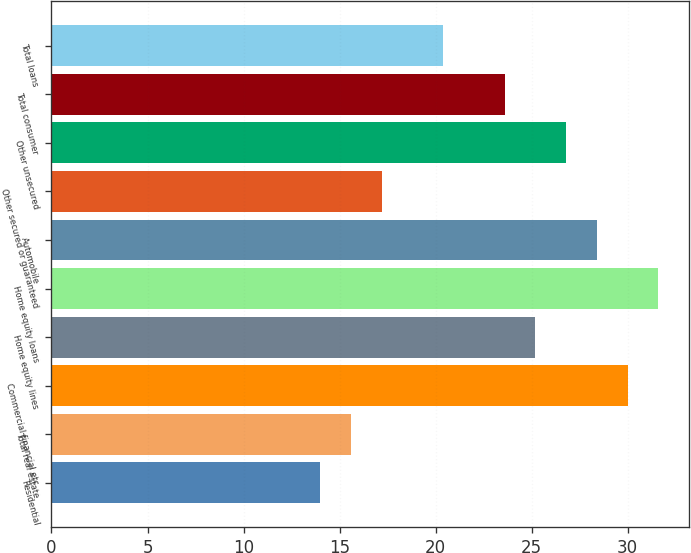Convert chart to OTSL. <chart><loc_0><loc_0><loc_500><loc_500><bar_chart><fcel>Residential<fcel>Total real estate<fcel>Commercial financial etc<fcel>Home equity lines<fcel>Home equity loans<fcel>Automobile<fcel>Other secured or guaranteed<fcel>Other unsecured<fcel>Total consumer<fcel>Total loans<nl><fcel>14<fcel>15.6<fcel>30<fcel>25.2<fcel>31.6<fcel>28.4<fcel>17.2<fcel>26.8<fcel>23.6<fcel>20.4<nl></chart> 